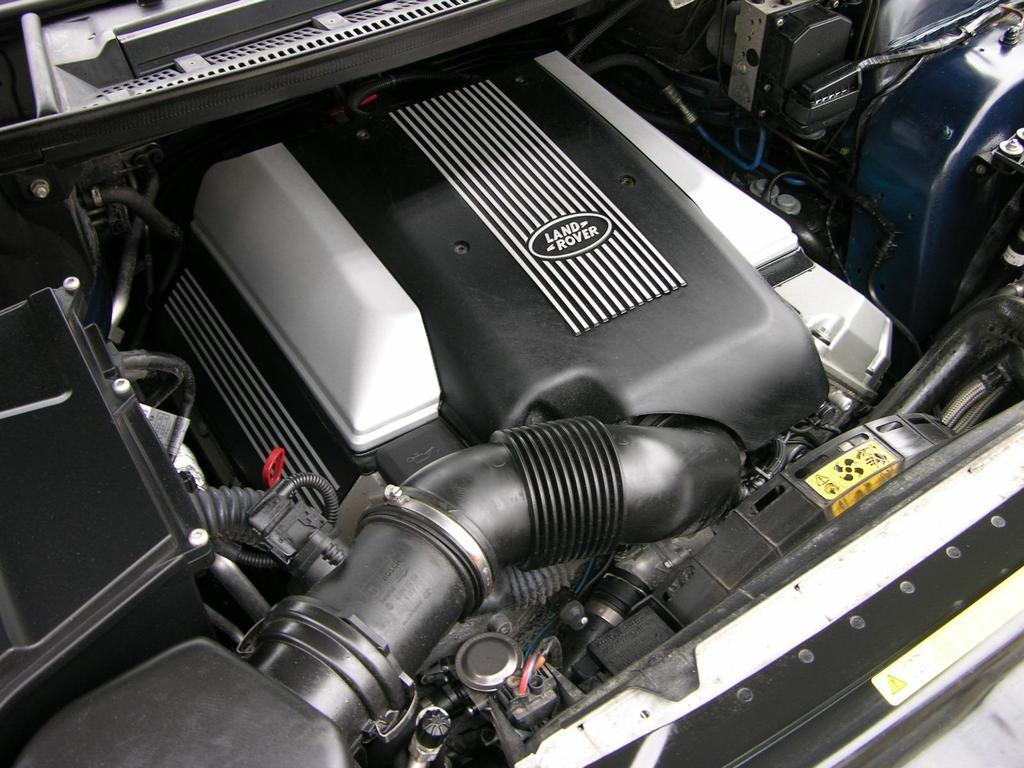What is the main subject of the image? The main subject of the image is an engine part of a vehicle. How many grapes are hanging from the twig in the image? There is no twig or grapes present in the image; it features an engine part of a vehicle. 